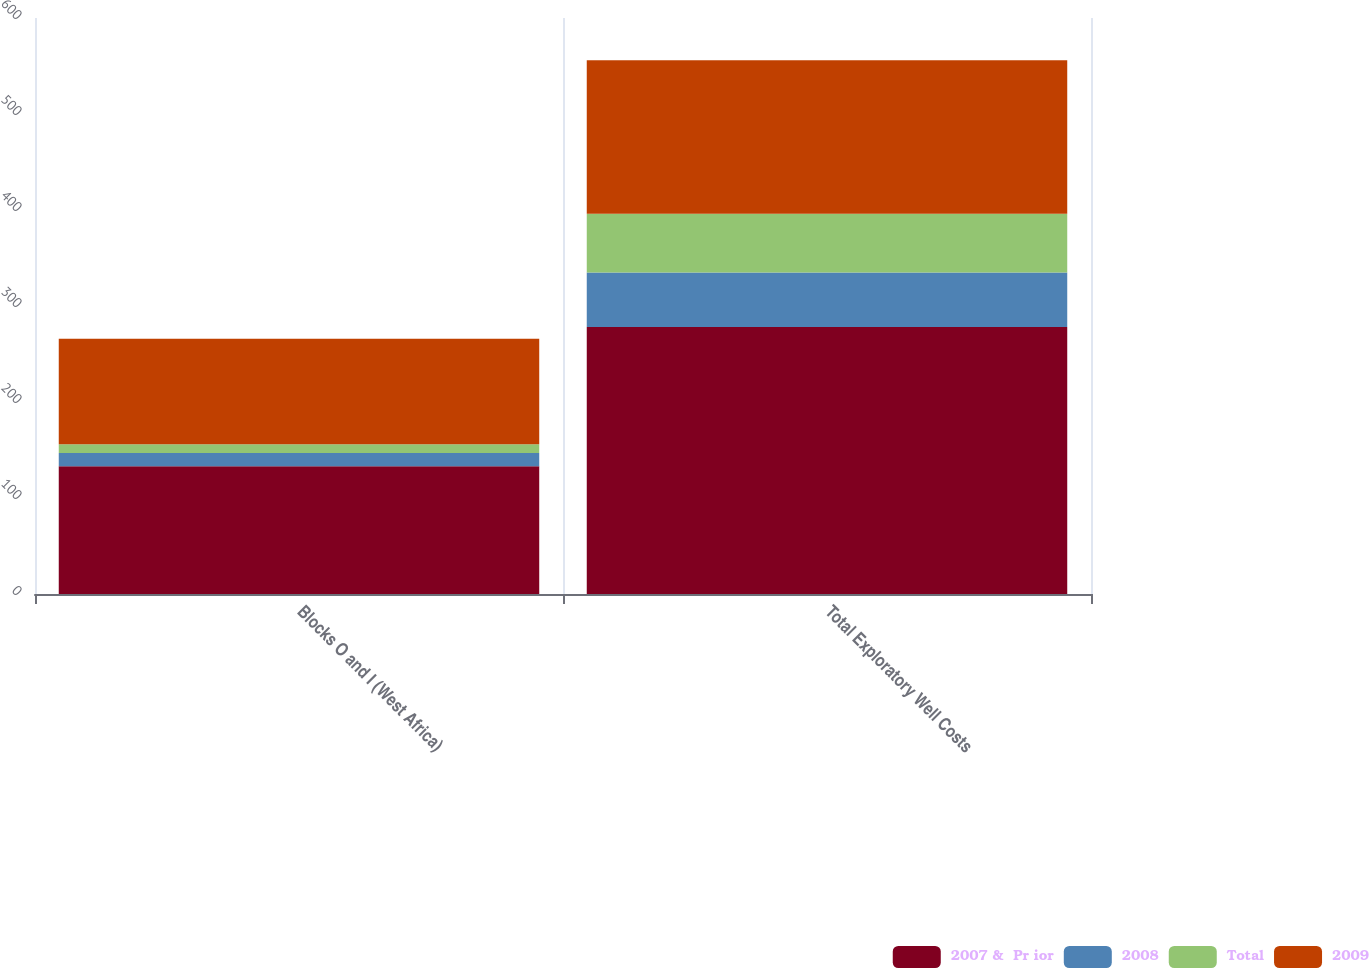Convert chart. <chart><loc_0><loc_0><loc_500><loc_500><stacked_bar_chart><ecel><fcel>Blocks O and I (West Africa)<fcel>Total Exploratory Well Costs<nl><fcel>2007 &  Pr ior<fcel>133<fcel>278<nl><fcel>2008<fcel>14<fcel>57<nl><fcel>Total<fcel>9<fcel>61<nl><fcel>2009<fcel>110<fcel>160<nl></chart> 